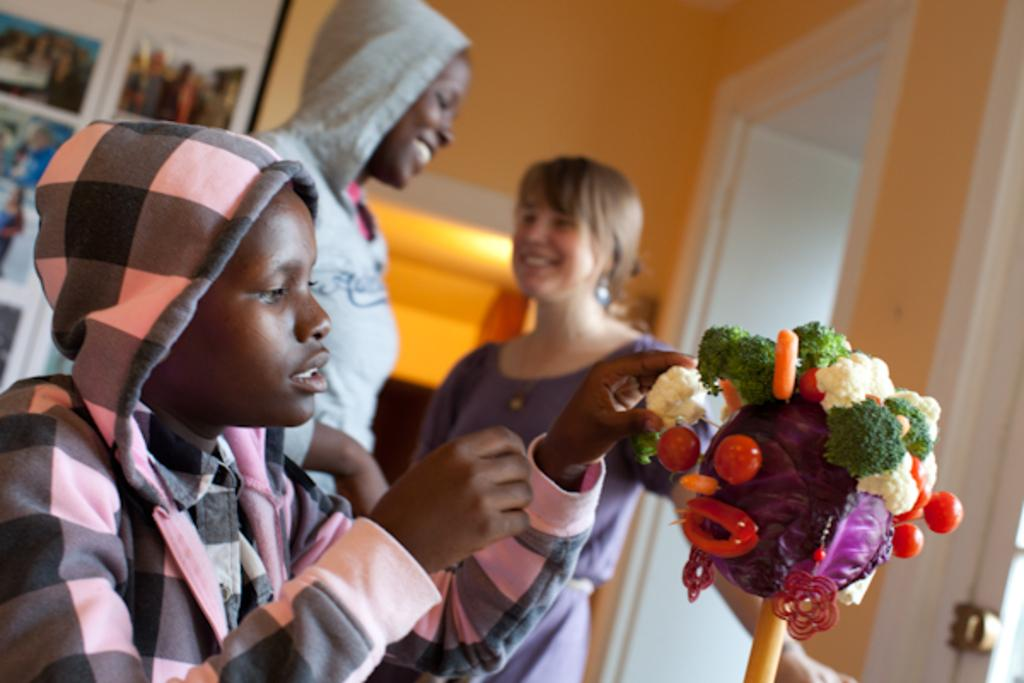What can be seen in the image? There is a group of people in the image. What else is visible on the right side of the image? There are vegetables on the right side of the image. Can you describe the background of the image? There is a light in the background of the image, and there are frames on the wall. How many pigs are standing on feet in the image? There are no pigs present in the image. What type of grape can be seen hanging from the frames on the wall? There is no grape present in the image, and the frames on the wall do not have any hanging objects. 